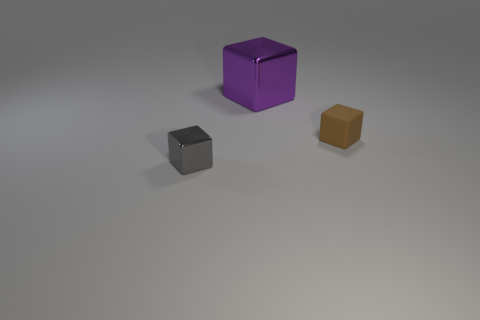There is a block that is behind the small object behind the tiny metal object; how big is it?
Your response must be concise. Large. Is the number of brown cubes that are left of the brown rubber cube less than the number of brown matte things?
Provide a succinct answer. Yes. Is the rubber block the same color as the large block?
Your answer should be compact. No. How big is the purple block?
Offer a very short reply. Large. How many other metallic cubes are the same color as the small metal block?
Keep it short and to the point. 0. There is a small thing that is behind the metal cube that is in front of the large shiny cube; are there any large metal objects that are right of it?
Provide a short and direct response. No. What is the shape of the metallic object that is the same size as the brown block?
Your answer should be very brief. Cube. What number of tiny objects are gray matte things or gray things?
Offer a terse response. 1. What is the color of the small object that is the same material as the purple cube?
Keep it short and to the point. Gray. There is a metal object that is to the left of the large block; is its shape the same as the thing behind the tiny brown rubber cube?
Offer a very short reply. Yes. 